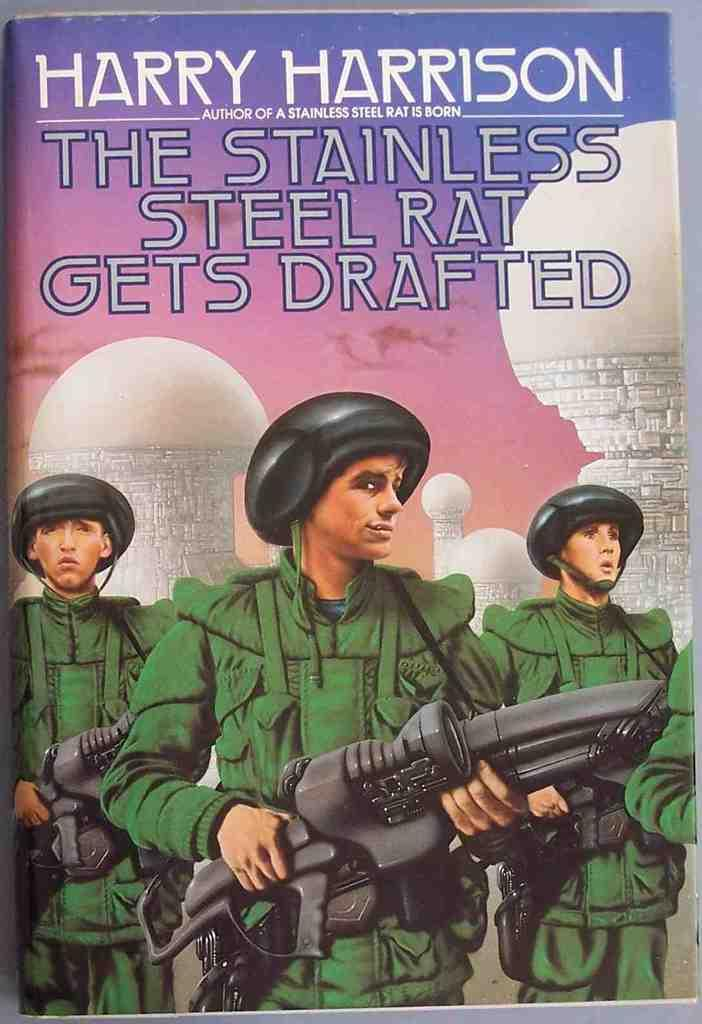<image>
Create a compact narrative representing the image presented. The army book is written by Harry Harrison. 